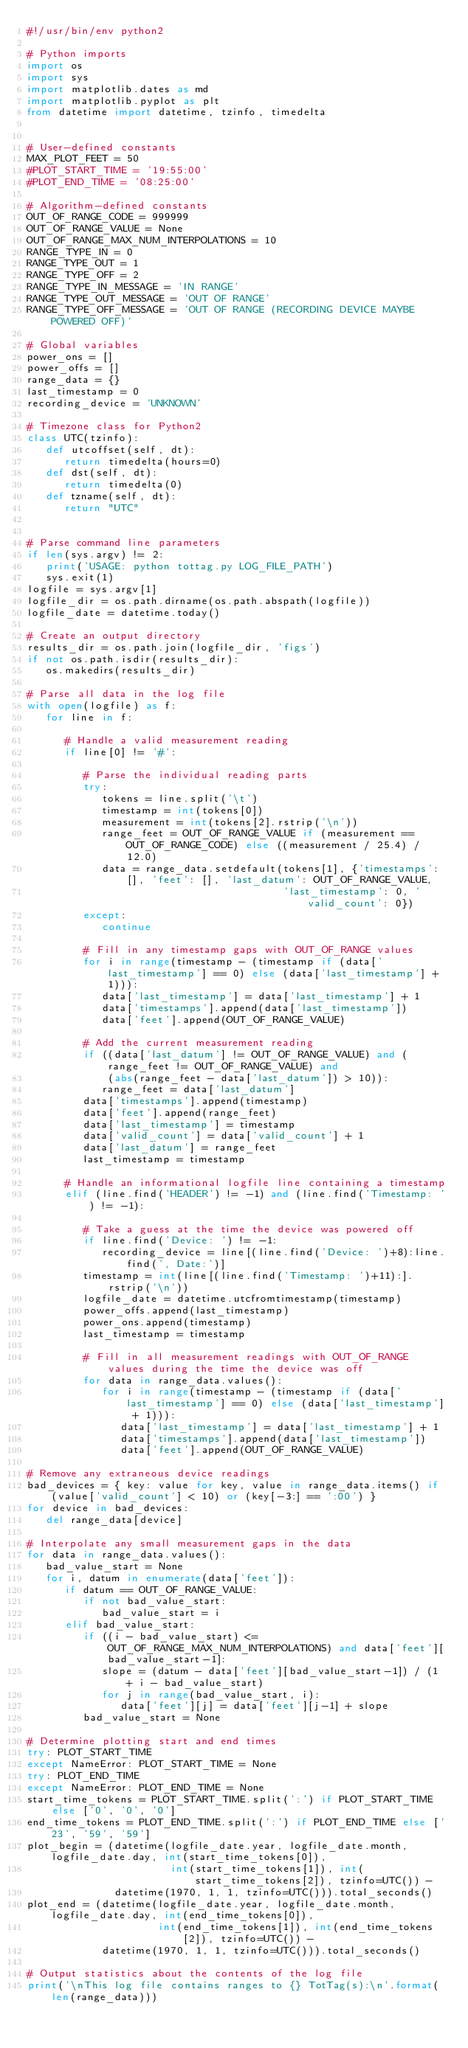<code> <loc_0><loc_0><loc_500><loc_500><_Python_>#!/usr/bin/env python2

# Python imports
import os
import sys
import matplotlib.dates as md
import matplotlib.pyplot as plt
from datetime import datetime, tzinfo, timedelta


# User-defined constants
MAX_PLOT_FEET = 50
#PLOT_START_TIME = '19:55:00'
#PLOT_END_TIME = '08:25:00'

# Algorithm-defined constants
OUT_OF_RANGE_CODE = 999999
OUT_OF_RANGE_VALUE = None
OUT_OF_RANGE_MAX_NUM_INTERPOLATIONS = 10
RANGE_TYPE_IN = 0
RANGE_TYPE_OUT = 1
RANGE_TYPE_OFF = 2
RANGE_TYPE_IN_MESSAGE = 'IN RANGE'
RANGE_TYPE_OUT_MESSAGE = 'OUT OF RANGE'
RANGE_TYPE_OFF_MESSAGE = 'OUT OF RANGE (RECORDING DEVICE MAYBE POWERED OFF)'

# Global variables
power_ons = []
power_offs = []
range_data = {}
last_timestamp = 0
recording_device = 'UNKNOWN'

# Timezone class for Python2
class UTC(tzinfo):
   def utcoffset(self, dt):
      return timedelta(hours=0)
   def dst(self, dt):
      return timedelta(0)
   def tzname(self, dt):
      return "UTC"


# Parse command line parameters
if len(sys.argv) != 2:
   print('USAGE: python tottag.py LOG_FILE_PATH')
   sys.exit(1)
logfile = sys.argv[1]
logfile_dir = os.path.dirname(os.path.abspath(logfile))
logfile_date = datetime.today()

# Create an output directory
results_dir = os.path.join(logfile_dir, 'figs')
if not os.path.isdir(results_dir):
   os.makedirs(results_dir)

# Parse all data in the log file
with open(logfile) as f:
   for line in f:

      # Handle a valid measurement reading
      if line[0] != '#':

         # Parse the individual reading parts
         try:
            tokens = line.split('\t')
            timestamp = int(tokens[0])
            measurement = int(tokens[2].rstrip('\n'))
            range_feet = OUT_OF_RANGE_VALUE if (measurement == OUT_OF_RANGE_CODE) else ((measurement / 25.4) / 12.0)
            data = range_data.setdefault(tokens[1], {'timestamps': [], 'feet': [], 'last_datum': OUT_OF_RANGE_VALUE,
                                         'last_timestamp': 0, 'valid_count': 0})
         except:
            continue

         # Fill in any timestamp gaps with OUT_OF_RANGE values
         for i in range(timestamp - (timestamp if (data['last_timestamp'] == 0) else (data['last_timestamp'] + 1))):
            data['last_timestamp'] = data['last_timestamp'] + 1
            data['timestamps'].append(data['last_timestamp'])
            data['feet'].append(OUT_OF_RANGE_VALUE)

         # Add the current measurement reading
         if ((data['last_datum'] != OUT_OF_RANGE_VALUE) and (range_feet != OUT_OF_RANGE_VALUE) and
             (abs(range_feet - data['last_datum']) > 10)):
            range_feet = data['last_datum']
         data['timestamps'].append(timestamp)
         data['feet'].append(range_feet)
         data['last_timestamp'] = timestamp
         data['valid_count'] = data['valid_count'] + 1
         data['last_datum'] = range_feet
         last_timestamp = timestamp

      # Handle an informational logfile line containing a timestamp
      elif (line.find('HEADER') != -1) and (line.find('Timestamp: ') != -1):

         # Take a guess at the time the device was powered off
         if line.find('Device: ') != -1:
            recording_device = line[(line.find('Device: ')+8):line.find(', Date:')]
         timestamp = int(line[(line.find('Timestamp: ')+11):].rstrip('\n'))
         logfile_date = datetime.utcfromtimestamp(timestamp)
         power_offs.append(last_timestamp)
         power_ons.append(timestamp)
         last_timestamp = timestamp

         # Fill in all measurement readings with OUT_OF_RANGE values during the time the device was off
         for data in range_data.values():
            for i in range(timestamp - (timestamp if (data['last_timestamp'] == 0) else (data['last_timestamp'] + 1))):
               data['last_timestamp'] = data['last_timestamp'] + 1
               data['timestamps'].append(data['last_timestamp'])
               data['feet'].append(OUT_OF_RANGE_VALUE)

# Remove any extraneous device readings
bad_devices = { key: value for key, value in range_data.items() if (value['valid_count'] < 10) or (key[-3:] == ':00') }
for device in bad_devices:
   del range_data[device]

# Interpolate any small measurement gaps in the data
for data in range_data.values():
   bad_value_start = None
   for i, datum in enumerate(data['feet']):
      if datum == OUT_OF_RANGE_VALUE:
         if not bad_value_start:
            bad_value_start = i
      elif bad_value_start:
         if ((i - bad_value_start) <= OUT_OF_RANGE_MAX_NUM_INTERPOLATIONS) and data['feet'][bad_value_start-1]:
            slope = (datum - data['feet'][bad_value_start-1]) / (1 + i - bad_value_start)
            for j in range(bad_value_start, i):
               data['feet'][j] = data['feet'][j-1] + slope
         bad_value_start = None

# Determine plotting start and end times
try: PLOT_START_TIME
except NameError: PLOT_START_TIME = None
try: PLOT_END_TIME
except NameError: PLOT_END_TIME = None
start_time_tokens = PLOT_START_TIME.split(':') if PLOT_START_TIME else ['0', '0', '0']
end_time_tokens = PLOT_END_TIME.split(':') if PLOT_END_TIME else ['23', '59', '59']
plot_begin = (datetime(logfile_date.year, logfile_date.month, logfile_date.day, int(start_time_tokens[0]),
                       int(start_time_tokens[1]), int(start_time_tokens[2]), tzinfo=UTC()) -
              datetime(1970, 1, 1, tzinfo=UTC())).total_seconds()
plot_end = (datetime(logfile_date.year, logfile_date.month, logfile_date.day, int(end_time_tokens[0]),
                     int(end_time_tokens[1]), int(end_time_tokens[2]), tzinfo=UTC()) -
            datetime(1970, 1, 1, tzinfo=UTC())).total_seconds()

# Output statistics about the contents of the log file
print('\nThis log file contains ranges to {} TotTag(s):\n'.format(len(range_data)))</code> 